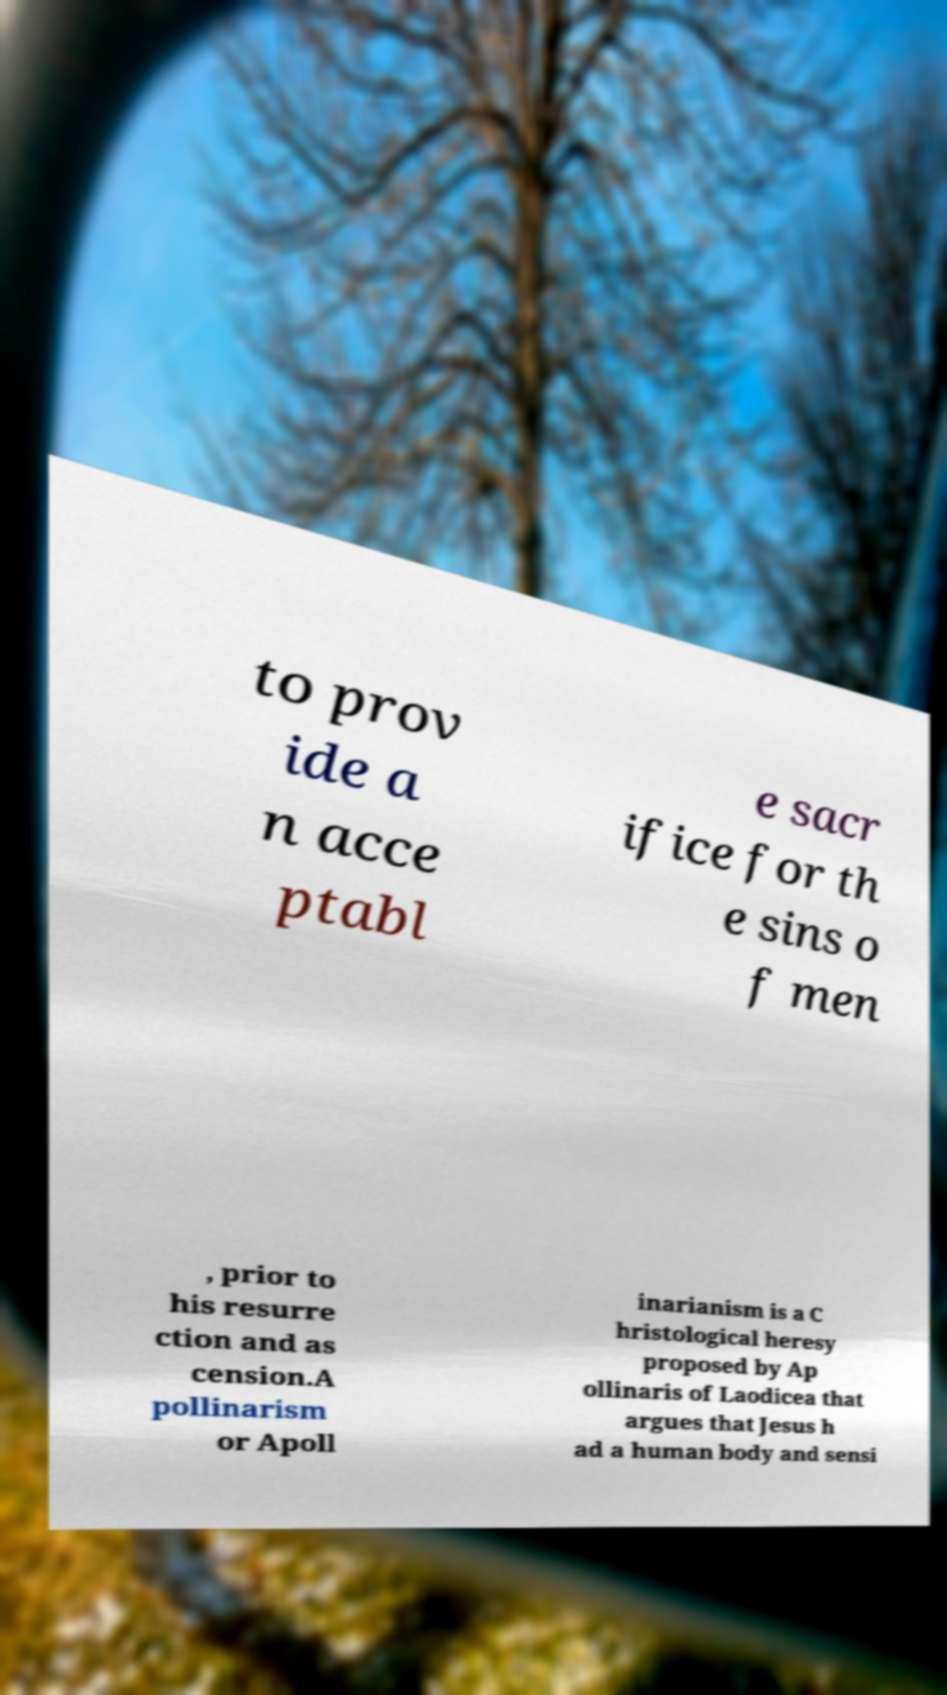Please read and relay the text visible in this image. What does it say? to prov ide a n acce ptabl e sacr ifice for th e sins o f men , prior to his resurre ction and as cension.A pollinarism or Apoll inarianism is a C hristological heresy proposed by Ap ollinaris of Laodicea that argues that Jesus h ad a human body and sensi 